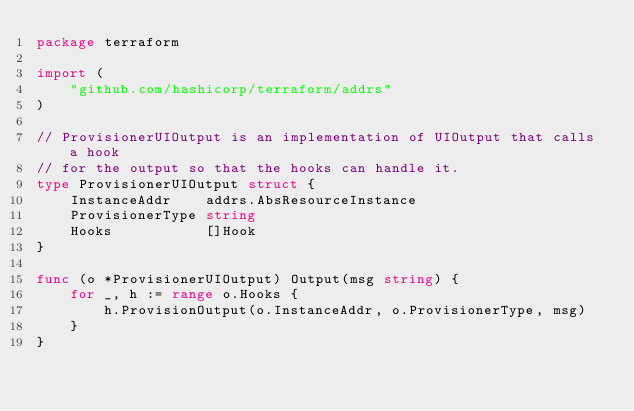<code> <loc_0><loc_0><loc_500><loc_500><_Go_>package terraform

import (
	"github.com/hashicorp/terraform/addrs"
)

// ProvisionerUIOutput is an implementation of UIOutput that calls a hook
// for the output so that the hooks can handle it.
type ProvisionerUIOutput struct {
	InstanceAddr    addrs.AbsResourceInstance
	ProvisionerType string
	Hooks           []Hook
}

func (o *ProvisionerUIOutput) Output(msg string) {
	for _, h := range o.Hooks {
		h.ProvisionOutput(o.InstanceAddr, o.ProvisionerType, msg)
	}
}
</code> 